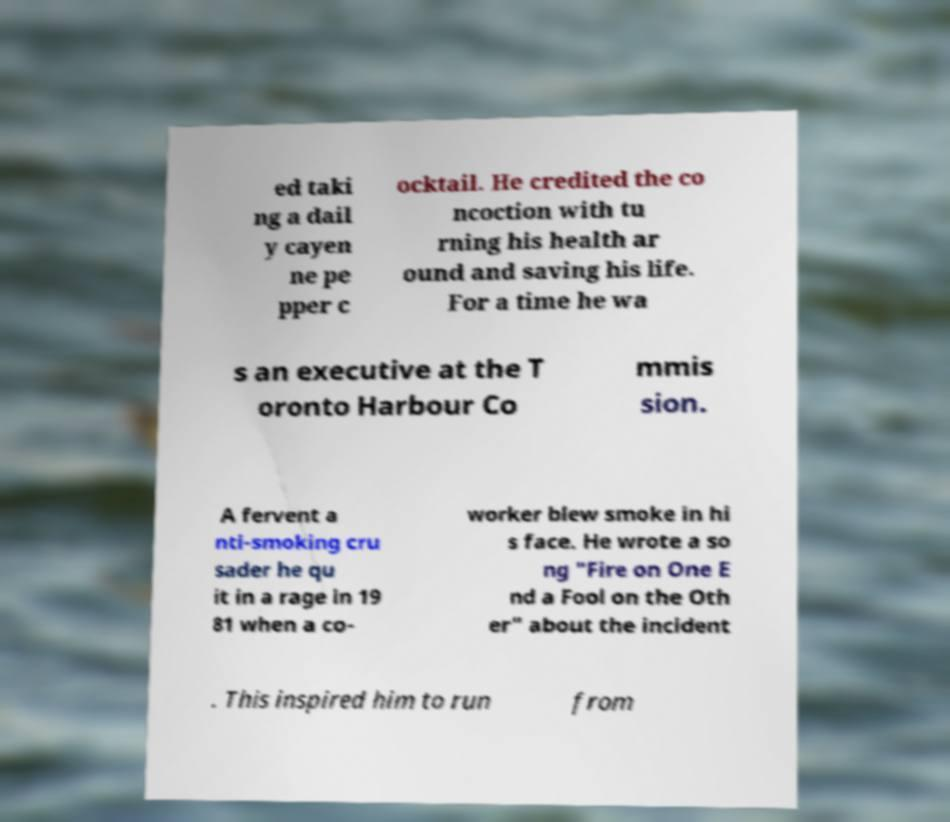Could you assist in decoding the text presented in this image and type it out clearly? ed taki ng a dail y cayen ne pe pper c ocktail. He credited the co ncoction with tu rning his health ar ound and saving his life. For a time he wa s an executive at the T oronto Harbour Co mmis sion. A fervent a nti-smoking cru sader he qu it in a rage in 19 81 when a co- worker blew smoke in hi s face. He wrote a so ng "Fire on One E nd a Fool on the Oth er" about the incident . This inspired him to run from 